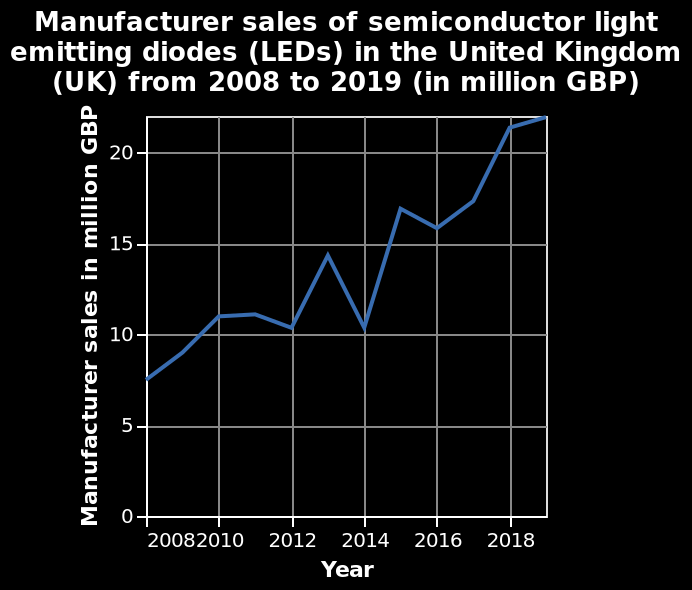<image>
Has the increase in Manufacturer sales of semiconductor light emitting diodes (LEDs) in the United Kingdom been continuous?  No, the increase has not been continuous as there have been years, like 2014, where the sales fell. Has the increase been continuous as there have been years, like 2014, where the sales rose? No. No, the increase has not been continuous as there have been years, like 2014, where the sales fell. 